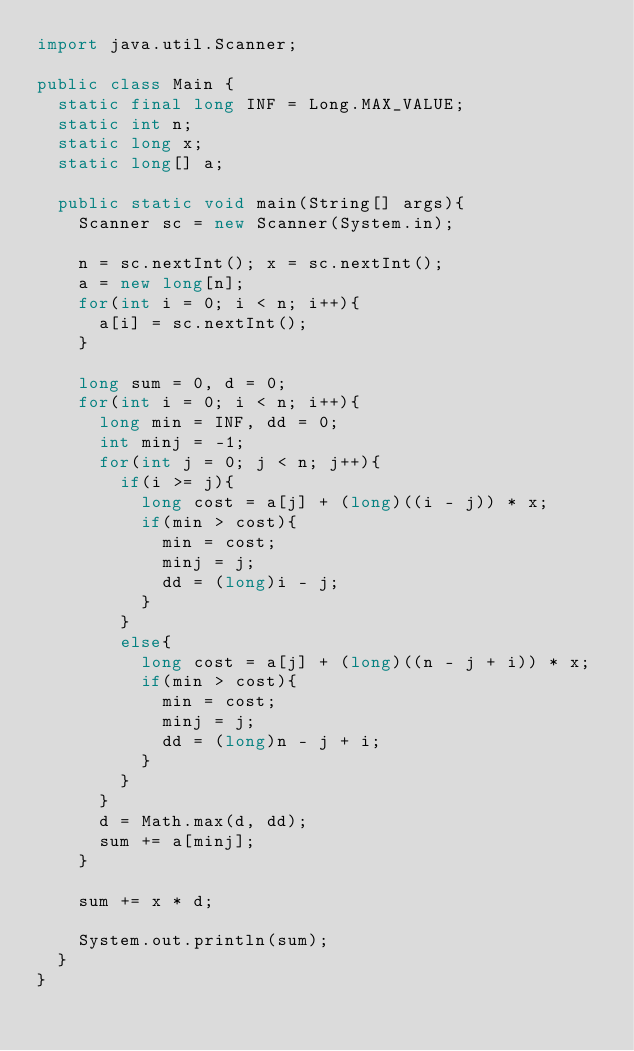<code> <loc_0><loc_0><loc_500><loc_500><_Java_>import java.util.Scanner;

public class Main {
  static final long INF = Long.MAX_VALUE;
  static int n;
  static long x;
  static long[] a;

  public static void main(String[] args){
    Scanner sc = new Scanner(System.in);

    n = sc.nextInt(); x = sc.nextInt();
    a = new long[n];
    for(int i = 0; i < n; i++){
      a[i] = sc.nextInt();
    }

    long sum = 0, d = 0;
    for(int i = 0; i < n; i++){
      long min = INF, dd = 0;
      int minj = -1;
      for(int j = 0; j < n; j++){
        if(i >= j){
          long cost = a[j] + (long)((i - j)) * x;
          if(min > cost){
            min = cost;
            minj = j;
            dd = (long)i - j;
          }
        }
        else{
          long cost = a[j] + (long)((n - j + i)) * x;
          if(min > cost){
            min = cost;
            minj = j;
            dd = (long)n - j + i;
          }
        }
      }
      d = Math.max(d, dd);
      sum += a[minj];
    }

    sum += x * d;

    System.out.println(sum);
  }
}</code> 